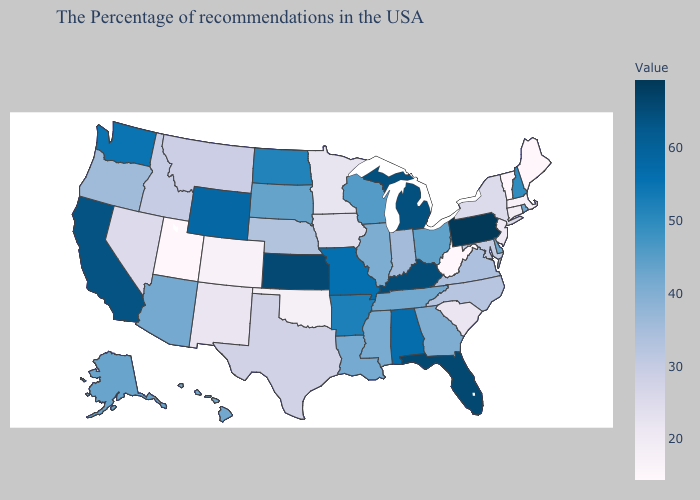Among the states that border Nevada , which have the highest value?
Answer briefly. California. Among the states that border Iowa , which have the highest value?
Give a very brief answer. Missouri. Does New Hampshire have the lowest value in the USA?
Quick response, please. No. Does Massachusetts have the highest value in the USA?
Short answer required. No. Does Pennsylvania have the highest value in the USA?
Concise answer only. Yes. 